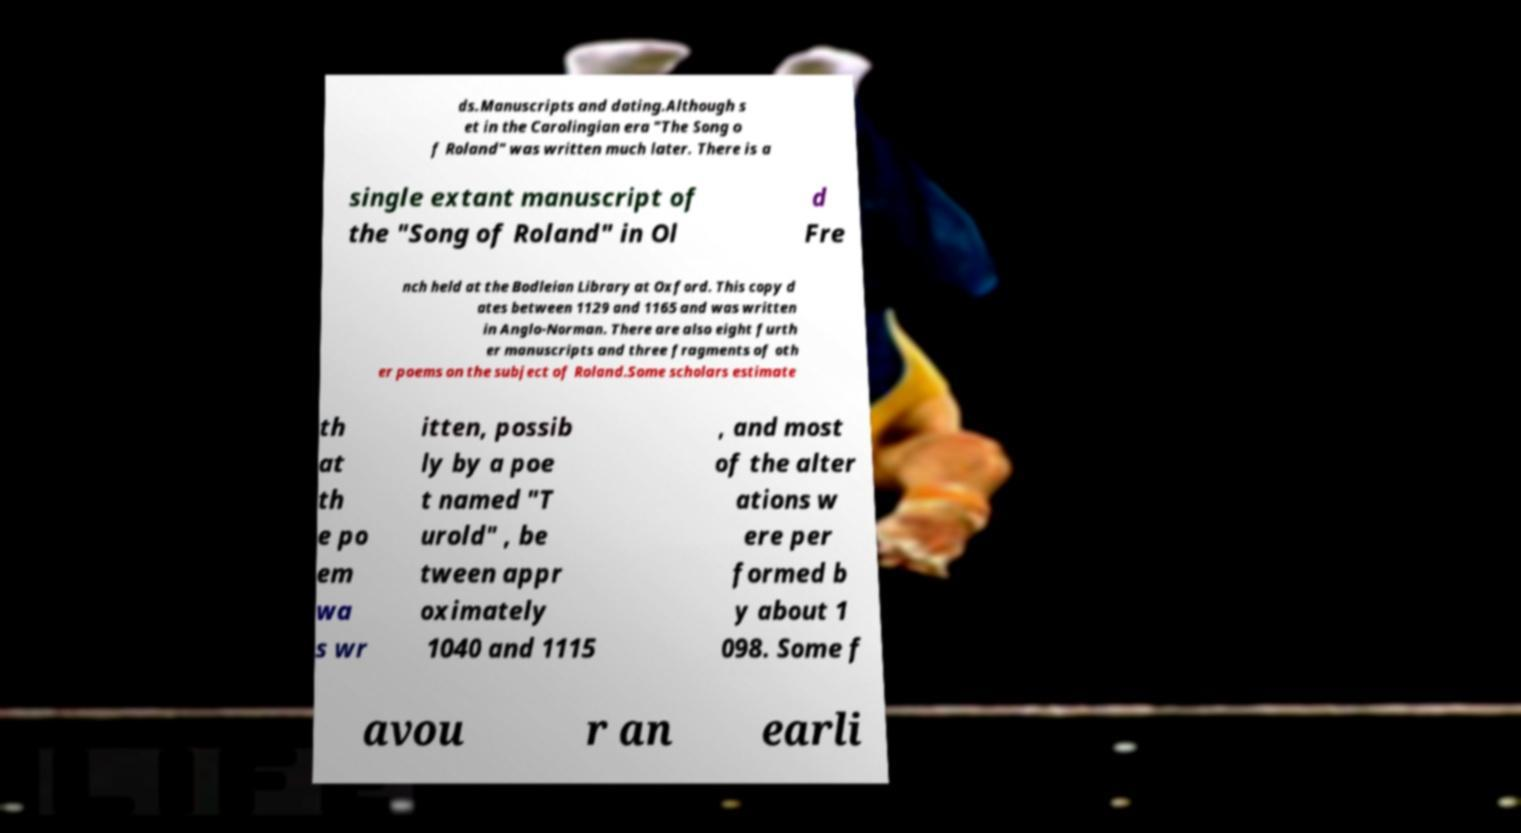I need the written content from this picture converted into text. Can you do that? ds.Manuscripts and dating.Although s et in the Carolingian era "The Song o f Roland" was written much later. There is a single extant manuscript of the "Song of Roland" in Ol d Fre nch held at the Bodleian Library at Oxford. This copy d ates between 1129 and 1165 and was written in Anglo-Norman. There are also eight furth er manuscripts and three fragments of oth er poems on the subject of Roland.Some scholars estimate th at th e po em wa s wr itten, possib ly by a poe t named "T urold" , be tween appr oximately 1040 and 1115 , and most of the alter ations w ere per formed b y about 1 098. Some f avou r an earli 